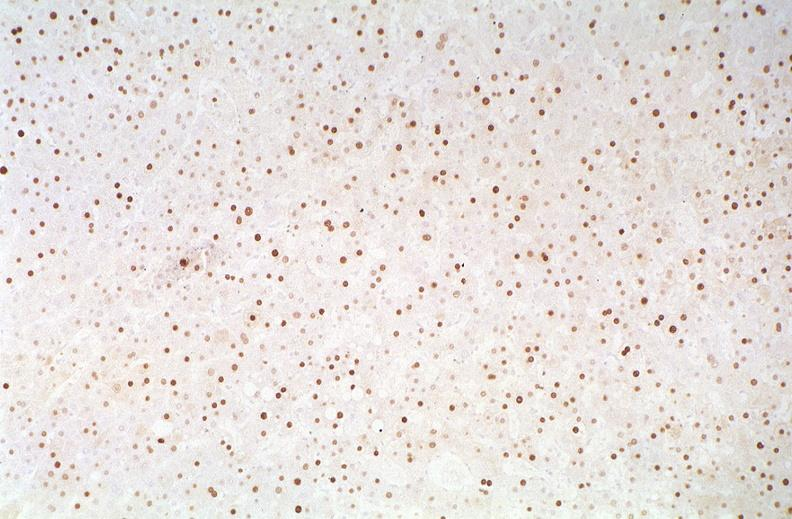s hepatobiliary present?
Answer the question using a single word or phrase. Yes 